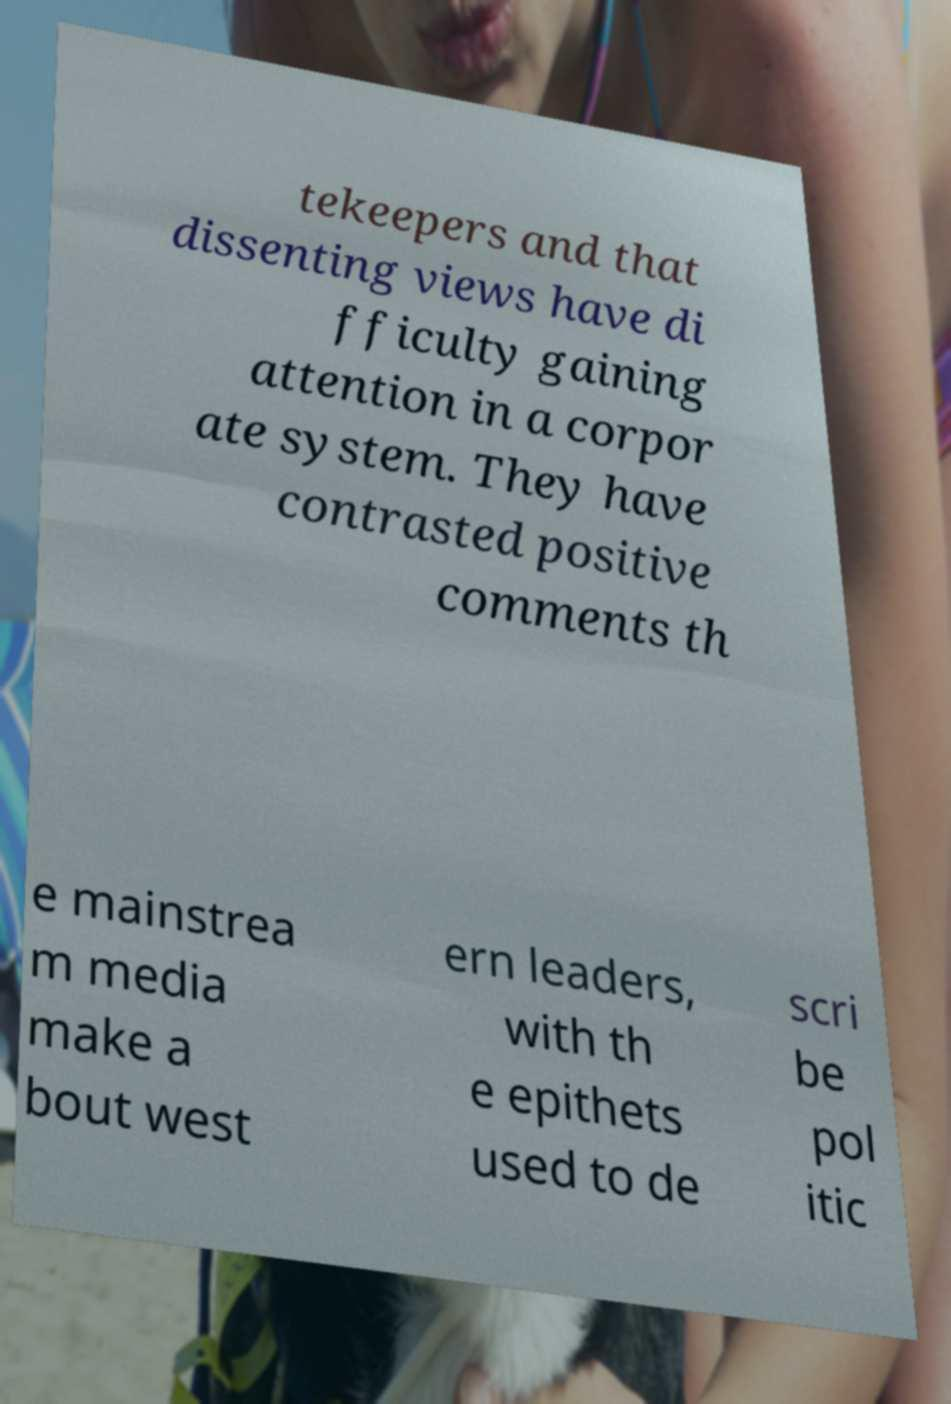I need the written content from this picture converted into text. Can you do that? tekeepers and that dissenting views have di fficulty gaining attention in a corpor ate system. They have contrasted positive comments th e mainstrea m media make a bout west ern leaders, with th e epithets used to de scri be pol itic 